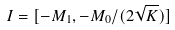Convert formula to latex. <formula><loc_0><loc_0><loc_500><loc_500>I = [ - M _ { 1 } , - M _ { 0 } / ( 2 \sqrt { K } ) ]</formula> 